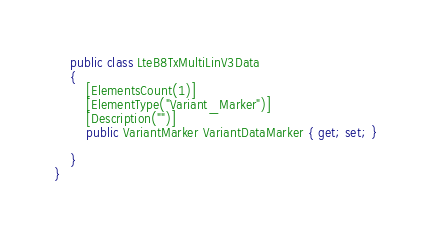Convert code to text. <code><loc_0><loc_0><loc_500><loc_500><_C#_>    public class LteB8TxMultiLinV3Data
    {
        [ElementsCount(1)]
        [ElementType("Variant_Marker")]
        [Description("")]
        public VariantMarker VariantDataMarker { get; set; }
        
    }
}
</code> 